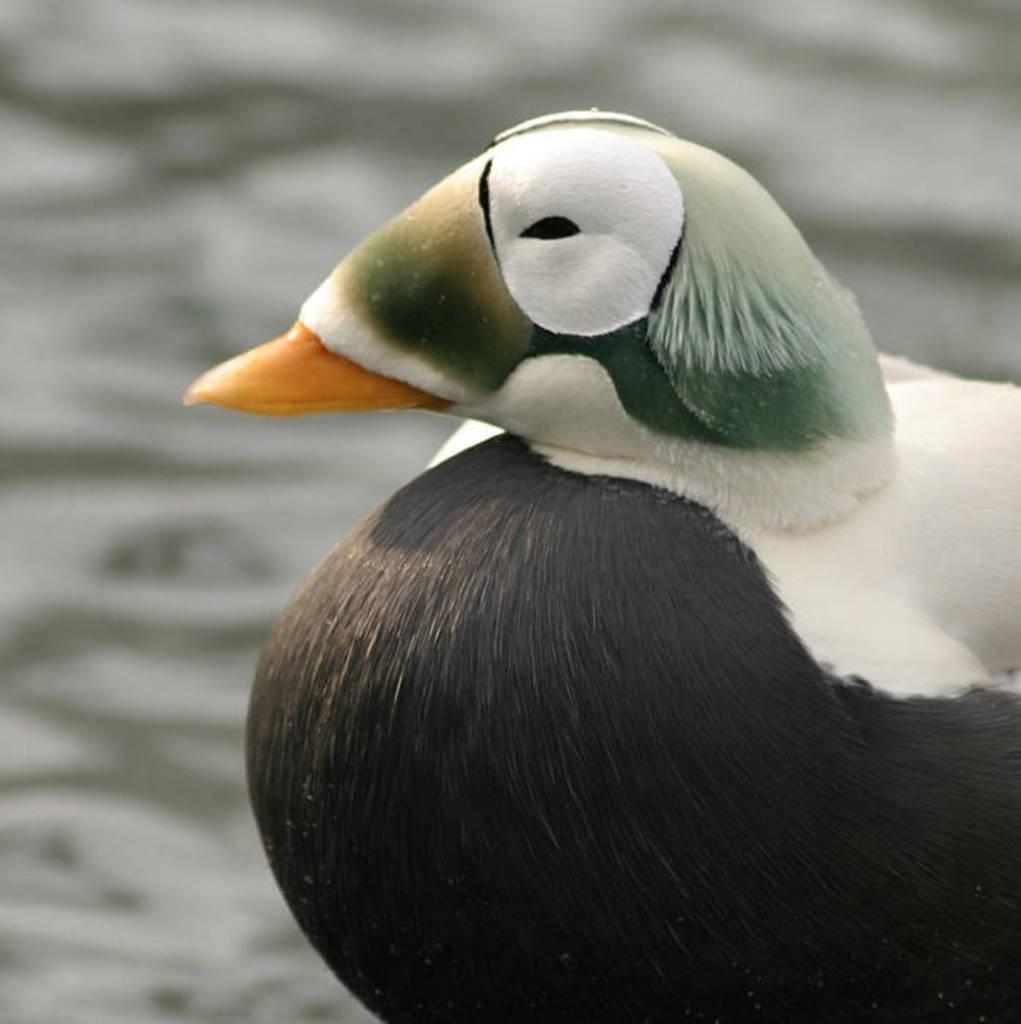What type of animal is present in the image? There is a bird in the image. How is the bird described? The bird is described as beautiful. What colors can be seen on the bird? The bird has black and white coloring. What type of collar is the bird wearing in the image? There is no collar present on the bird in the image. What ornament is hanging from the bird's beak in the image? There is no ornament present on the bird's beak in the image. 